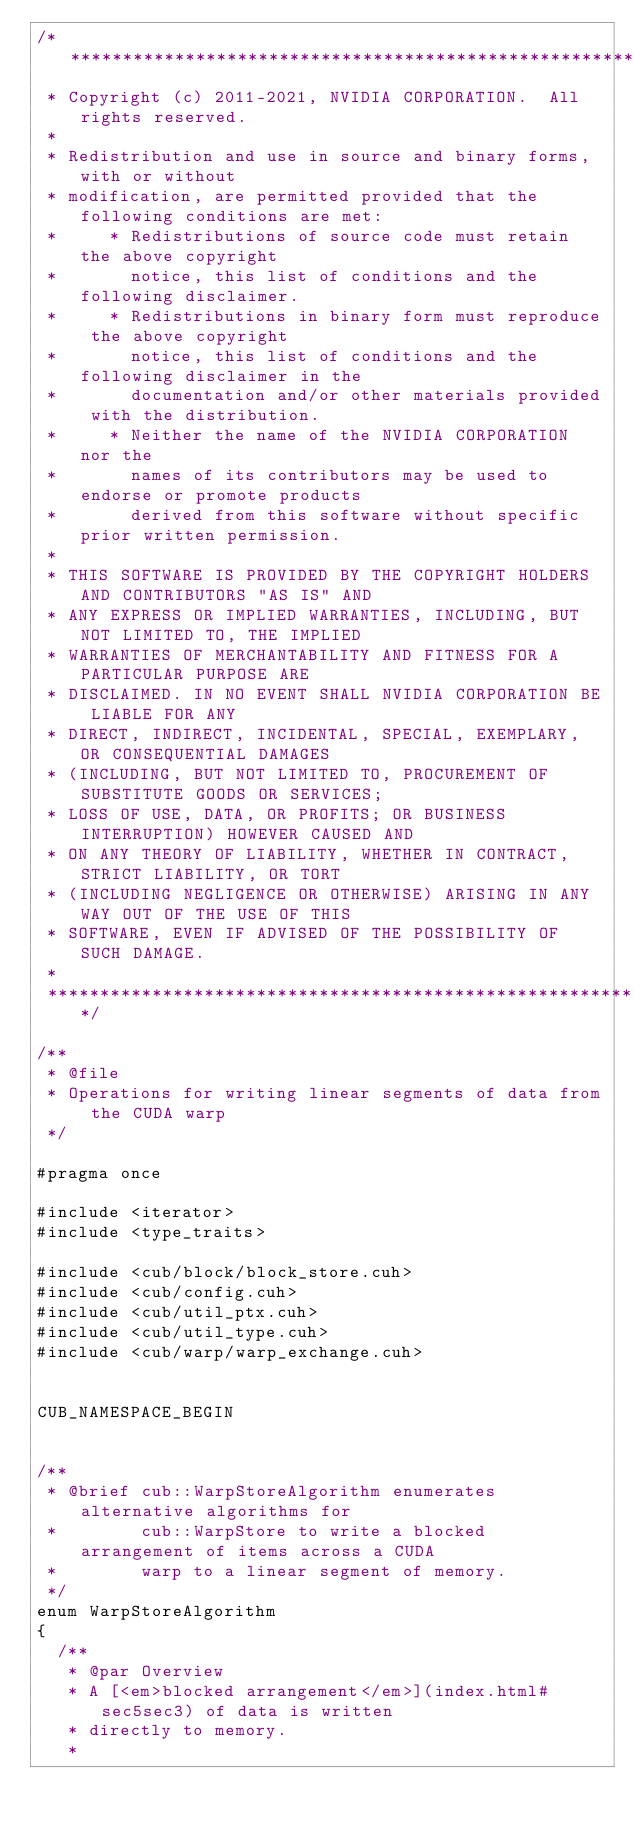Convert code to text. <code><loc_0><loc_0><loc_500><loc_500><_Cuda_>/******************************************************************************
 * Copyright (c) 2011-2021, NVIDIA CORPORATION.  All rights reserved.
 *
 * Redistribution and use in source and binary forms, with or without
 * modification, are permitted provided that the following conditions are met:
 *     * Redistributions of source code must retain the above copyright
 *       notice, this list of conditions and the following disclaimer.
 *     * Redistributions in binary form must reproduce the above copyright
 *       notice, this list of conditions and the following disclaimer in the
 *       documentation and/or other materials provided with the distribution.
 *     * Neither the name of the NVIDIA CORPORATION nor the
 *       names of its contributors may be used to endorse or promote products
 *       derived from this software without specific prior written permission.
 *
 * THIS SOFTWARE IS PROVIDED BY THE COPYRIGHT HOLDERS AND CONTRIBUTORS "AS IS" AND
 * ANY EXPRESS OR IMPLIED WARRANTIES, INCLUDING, BUT NOT LIMITED TO, THE IMPLIED
 * WARRANTIES OF MERCHANTABILITY AND FITNESS FOR A PARTICULAR PURPOSE ARE
 * DISCLAIMED. IN NO EVENT SHALL NVIDIA CORPORATION BE LIABLE FOR ANY
 * DIRECT, INDIRECT, INCIDENTAL, SPECIAL, EXEMPLARY, OR CONSEQUENTIAL DAMAGES
 * (INCLUDING, BUT NOT LIMITED TO, PROCUREMENT OF SUBSTITUTE GOODS OR SERVICES;
 * LOSS OF USE, DATA, OR PROFITS; OR BUSINESS INTERRUPTION) HOWEVER CAUSED AND
 * ON ANY THEORY OF LIABILITY, WHETHER IN CONTRACT, STRICT LIABILITY, OR TORT
 * (INCLUDING NEGLIGENCE OR OTHERWISE) ARISING IN ANY WAY OUT OF THE USE OF THIS
 * SOFTWARE, EVEN IF ADVISED OF THE POSSIBILITY OF SUCH DAMAGE.
 *
 ******************************************************************************/

/**
 * @file
 * Operations for writing linear segments of data from the CUDA warp
 */

#pragma once

#include <iterator>
#include <type_traits>

#include <cub/block/block_store.cuh>
#include <cub/config.cuh>
#include <cub/util_ptx.cuh>
#include <cub/util_type.cuh>
#include <cub/warp/warp_exchange.cuh>


CUB_NAMESPACE_BEGIN


/**
 * @brief cub::WarpStoreAlgorithm enumerates alternative algorithms for
 *        cub::WarpStore to write a blocked arrangement of items across a CUDA
 *        warp to a linear segment of memory.
 */
enum WarpStoreAlgorithm
{
  /**
   * @par Overview
   * A [<em>blocked arrangement</em>](index.html#sec5sec3) of data is written
   * directly to memory.
   *</code> 